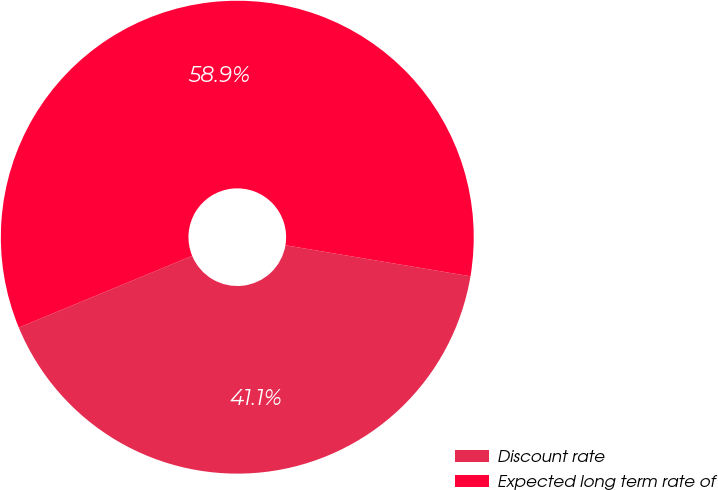Convert chart. <chart><loc_0><loc_0><loc_500><loc_500><pie_chart><fcel>Discount rate<fcel>Expected long term rate of<nl><fcel>41.11%<fcel>58.89%<nl></chart> 